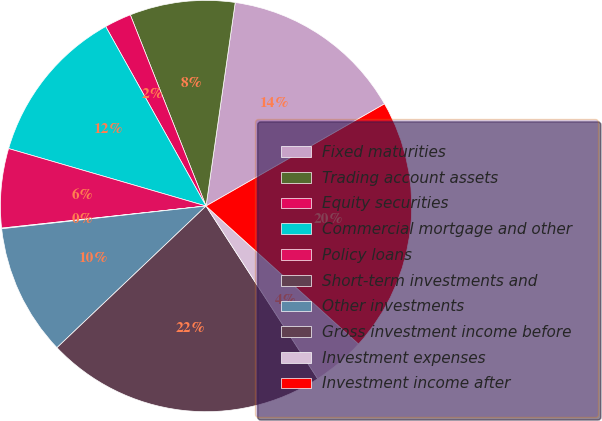Convert chart to OTSL. <chart><loc_0><loc_0><loc_500><loc_500><pie_chart><fcel>Fixed maturities<fcel>Trading account assets<fcel>Equity securities<fcel>Commercial mortgage and other<fcel>Policy loans<fcel>Short-term investments and<fcel>Other investments<fcel>Gross investment income before<fcel>Investment expenses<fcel>Investment income after<nl><fcel>14.46%<fcel>8.27%<fcel>2.11%<fcel>12.38%<fcel>6.22%<fcel>0.05%<fcel>10.33%<fcel>22.04%<fcel>4.16%<fcel>19.98%<nl></chart> 